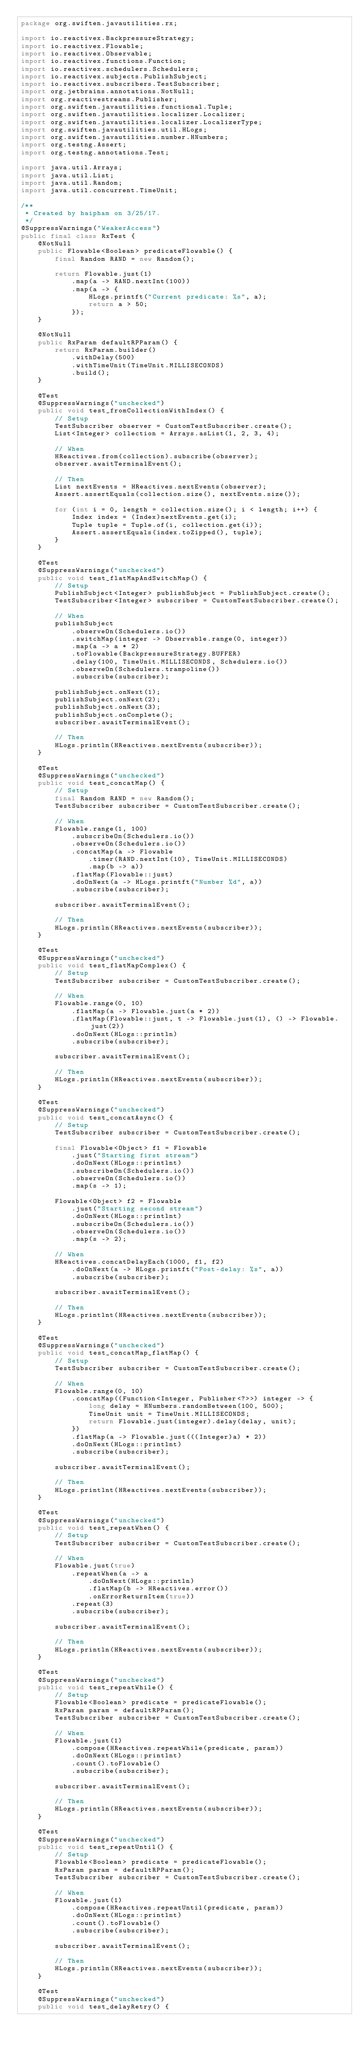Convert code to text. <code><loc_0><loc_0><loc_500><loc_500><_Java_>package org.swiften.javautilities.rx;

import io.reactivex.BackpressureStrategy;
import io.reactivex.Flowable;
import io.reactivex.Observable;
import io.reactivex.functions.Function;
import io.reactivex.schedulers.Schedulers;
import io.reactivex.subjects.PublishSubject;
import io.reactivex.subscribers.TestSubscriber;
import org.jetbrains.annotations.NotNull;
import org.reactivestreams.Publisher;
import org.swiften.javautilities.functional.Tuple;
import org.swiften.javautilities.localizer.Localizer;
import org.swiften.javautilities.localizer.LocalizerType;
import org.swiften.javautilities.util.HLogs;
import org.swiften.javautilities.number.HNumbers;
import org.testng.Assert;
import org.testng.annotations.Test;

import java.util.Arrays;
import java.util.List;
import java.util.Random;
import java.util.concurrent.TimeUnit;

/**
 * Created by haipham on 3/25/17.
 */
@SuppressWarnings("WeakerAccess")
public final class RxTest {
    @NotNull
    public Flowable<Boolean> predicateFlowable() {
        final Random RAND = new Random();

        return Flowable.just(1)
            .map(a -> RAND.nextInt(100))
            .map(a -> {
                HLogs.printft("Current predicate: %s", a);
                return a > 50;
            });
    }

    @NotNull
    public RxParam defaultRPParam() {
        return RxParam.builder()
            .withDelay(500)
            .withTimeUnit(TimeUnit.MILLISECONDS)
            .build();
    }

    @Test
    @SuppressWarnings("unchecked")
    public void test_fromCollectionWithIndex() {
        // Setup
        TestSubscriber observer = CustomTestSubscriber.create();
        List<Integer> collection = Arrays.asList(1, 2, 3, 4);

        // When
        HReactives.from(collection).subscribe(observer);
        observer.awaitTerminalEvent();

        // Then
        List nextEvents = HReactives.nextEvents(observer);
        Assert.assertEquals(collection.size(), nextEvents.size());

        for (int i = 0, length = collection.size(); i < length; i++) {
            Index index = (Index)nextEvents.get(i);
            Tuple tuple = Tuple.of(i, collection.get(i));
            Assert.assertEquals(index.toZipped(), tuple);
        }
    }

    @Test
    @SuppressWarnings("unchecked")
    public void test_flatMapAndSwitchMap() {
        // Setup
        PublishSubject<Integer> publishSubject = PublishSubject.create();
        TestSubscriber<Integer> subscriber = CustomTestSubscriber.create();

        // When
        publishSubject
            .observeOn(Schedulers.io())
            .switchMap(integer -> Observable.range(0, integer))
            .map(a -> a * 2)
            .toFlowable(BackpressureStrategy.BUFFER)
            .delay(100, TimeUnit.MILLISECONDS, Schedulers.io())
            .observeOn(Schedulers.trampoline())
            .subscribe(subscriber);

        publishSubject.onNext(1);
        publishSubject.onNext(2);
        publishSubject.onNext(3);
        publishSubject.onComplete();
        subscriber.awaitTerminalEvent();

        // Then
        HLogs.println(HReactives.nextEvents(subscriber));
    }

    @Test
    @SuppressWarnings("unchecked")
    public void test_concatMap() {
        // Setup
        final Random RAND = new Random();
        TestSubscriber subscriber = CustomTestSubscriber.create();

        // When
        Flowable.range(1, 100)
            .subscribeOn(Schedulers.io())
            .observeOn(Schedulers.io())
            .concatMap(a -> Flowable
                .timer(RAND.nextInt(10), TimeUnit.MILLISECONDS)
                .map(b -> a))
            .flatMap(Flowable::just)
            .doOnNext(a -> HLogs.printft("Number %d", a))
            .subscribe(subscriber);

        subscriber.awaitTerminalEvent();

        // Then
        HLogs.println(HReactives.nextEvents(subscriber));
    }

    @Test
    @SuppressWarnings("unchecked")
    public void test_flatMapComplex() {
        // Setup
        TestSubscriber subscriber = CustomTestSubscriber.create();

        // When
        Flowable.range(0, 10)
            .flatMap(a -> Flowable.just(a * 2))
            .flatMap(Flowable::just, t -> Flowable.just(1), () -> Flowable.just(2))
            .doOnNext(HLogs::println)
            .subscribe(subscriber);

        subscriber.awaitTerminalEvent();

        // Then
        HLogs.println(HReactives.nextEvents(subscriber));
    }

    @Test
    @SuppressWarnings("unchecked")
    public void test_concatAsync() {
        // Setup
        TestSubscriber subscriber = CustomTestSubscriber.create();

        final Flowable<Object> f1 = Flowable
            .just("Starting first stream")
            .doOnNext(HLogs::printlnt)
            .subscribeOn(Schedulers.io())
            .observeOn(Schedulers.io())
            .map(s -> 1);

        Flowable<Object> f2 = Flowable
            .just("Starting second stream")
            .doOnNext(HLogs::printlnt)
            .subscribeOn(Schedulers.io())
            .observeOn(Schedulers.io())
            .map(s -> 2);

        // When
        HReactives.concatDelayEach(1000, f1, f2)
            .doOnNext(a -> HLogs.printft("Post-delay: %s", a))
            .subscribe(subscriber);

        subscriber.awaitTerminalEvent();

        // Then
        HLogs.printlnt(HReactives.nextEvents(subscriber));
    }

    @Test
    @SuppressWarnings("unchecked")
    public void test_concatMap_flatMap() {
        // Setup
        TestSubscriber subscriber = CustomTestSubscriber.create();

        // When
        Flowable.range(0, 10)
            .concatMap((Function<Integer, Publisher<?>>) integer -> {
                long delay = HNumbers.randomBetween(100, 500);
                TimeUnit unit = TimeUnit.MILLISECONDS;
                return Flowable.just(integer).delay(delay, unit);
            })
            .flatMap(a -> Flowable.just(((Integer)a) * 2))
            .doOnNext(HLogs::printlnt)
            .subscribe(subscriber);

        subscriber.awaitTerminalEvent();

        // Then
        HLogs.printlnt(HReactives.nextEvents(subscriber));
    }

    @Test
    @SuppressWarnings("unchecked")
    public void test_repeatWhen() {
        // Setup
        TestSubscriber subscriber = CustomTestSubscriber.create();

        // When
        Flowable.just(true)
            .repeatWhen(a -> a
                .doOnNext(HLogs::println)
                .flatMap(b -> HReactives.error())
                .onErrorReturnItem(true))
            .repeat(3)
            .subscribe(subscriber);

        subscriber.awaitTerminalEvent();

        // Then
        HLogs.println(HReactives.nextEvents(subscriber));
    }

    @Test
    @SuppressWarnings("unchecked")
    public void test_repeatWhile() {
        // Setup
        Flowable<Boolean> predicate = predicateFlowable();
        RxParam param = defaultRPParam();
        TestSubscriber subscriber = CustomTestSubscriber.create();

        // When
        Flowable.just(1)
            .compose(HReactives.repeatWhile(predicate, param))
            .doOnNext(HLogs::printlnt)
            .count().toFlowable()
            .subscribe(subscriber);

        subscriber.awaitTerminalEvent();

        // Then
        HLogs.println(HReactives.nextEvents(subscriber));
    }

    @Test
    @SuppressWarnings("unchecked")
    public void test_repeatUntil() {
        // Setup
        Flowable<Boolean> predicate = predicateFlowable();
        RxParam param = defaultRPParam();
        TestSubscriber subscriber = CustomTestSubscriber.create();

        // When
        Flowable.just(1)
            .compose(HReactives.repeatUntil(predicate, param))
            .doOnNext(HLogs::printlnt)
            .count().toFlowable()
            .subscribe(subscriber);

        subscriber.awaitTerminalEvent();

        // Then
        HLogs.println(HReactives.nextEvents(subscriber));
    }

    @Test
    @SuppressWarnings("unchecked")
    public void test_delayRetry() {</code> 